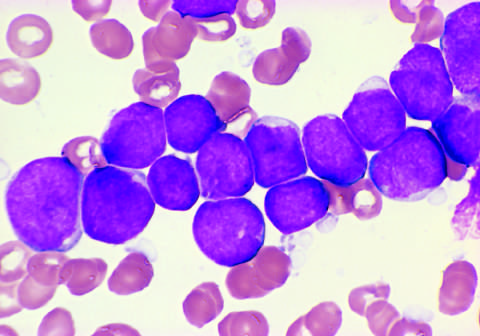what results for the all are shown in the figure?
Answer the question using a single word or phrase. Flow cytometry 